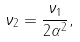Convert formula to latex. <formula><loc_0><loc_0><loc_500><loc_500>\nu _ { 2 } = \frac { \nu _ { 1 } } { 2 \alpha ^ { 2 } } ,</formula> 